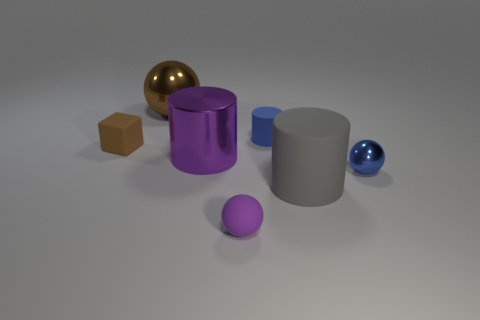The tiny brown rubber object behind the metal thing right of the small cylinder is what shape?
Your answer should be compact. Cube. What number of small things are to the left of the shiny ball that is on the right side of the big purple cylinder?
Your response must be concise. 3. There is a cylinder that is in front of the brown block and right of the metallic cylinder; what is its material?
Ensure brevity in your answer.  Rubber. There is a rubber object that is the same size as the brown sphere; what shape is it?
Provide a short and direct response. Cylinder. There is a sphere that is right of the sphere in front of the metallic object that is right of the gray rubber object; what is its color?
Your response must be concise. Blue. What number of things are tiny matte objects on the left side of the big brown thing or blue matte cylinders?
Your answer should be compact. 2. What material is the purple sphere that is the same size as the blue rubber cylinder?
Give a very brief answer. Rubber. What material is the brown thing that is right of the small thing left of the small rubber thing in front of the tiny brown matte thing?
Provide a succinct answer. Metal. What color is the rubber block?
Give a very brief answer. Brown. How many big objects are either cyan matte balls or brown rubber things?
Your answer should be very brief. 0. 